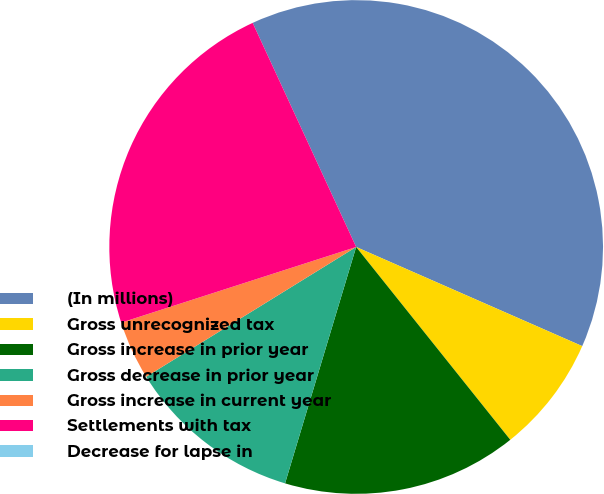Convert chart. <chart><loc_0><loc_0><loc_500><loc_500><pie_chart><fcel>(In millions)<fcel>Gross unrecognized tax<fcel>Gross increase in prior year<fcel>Gross decrease in prior year<fcel>Gross increase in current year<fcel>Settlements with tax<fcel>Decrease for lapse in<nl><fcel>38.46%<fcel>7.69%<fcel>15.38%<fcel>11.54%<fcel>3.85%<fcel>23.07%<fcel>0.0%<nl></chart> 